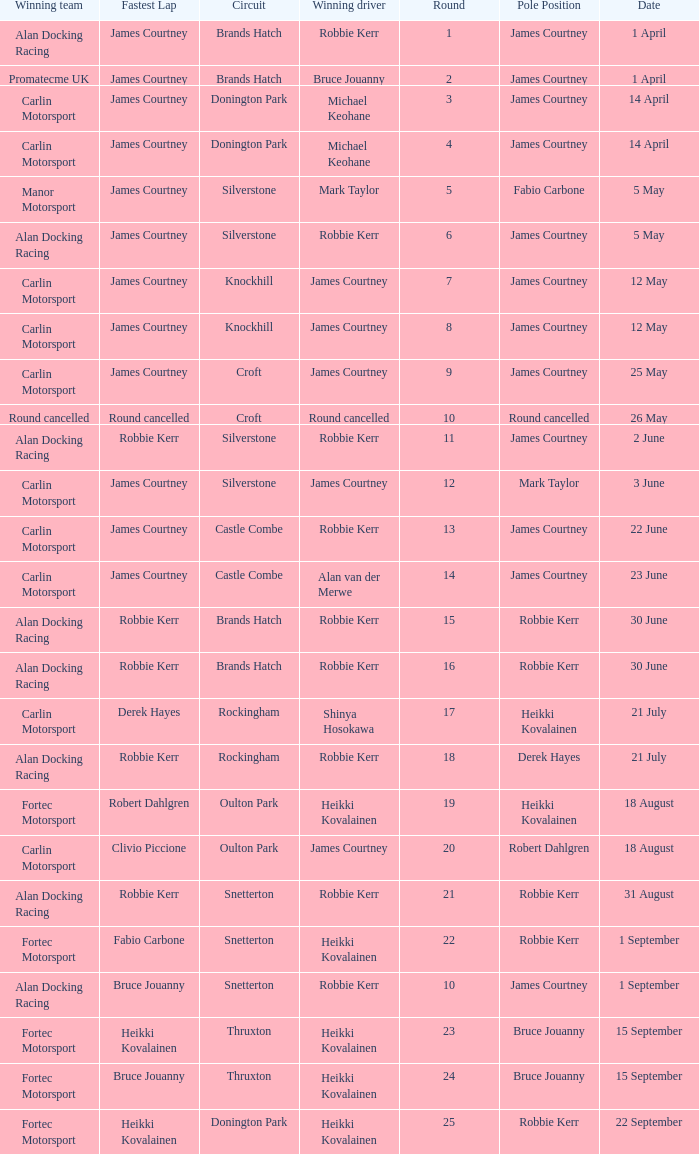What is every date of Mark Taylor as winning driver? 5 May. 